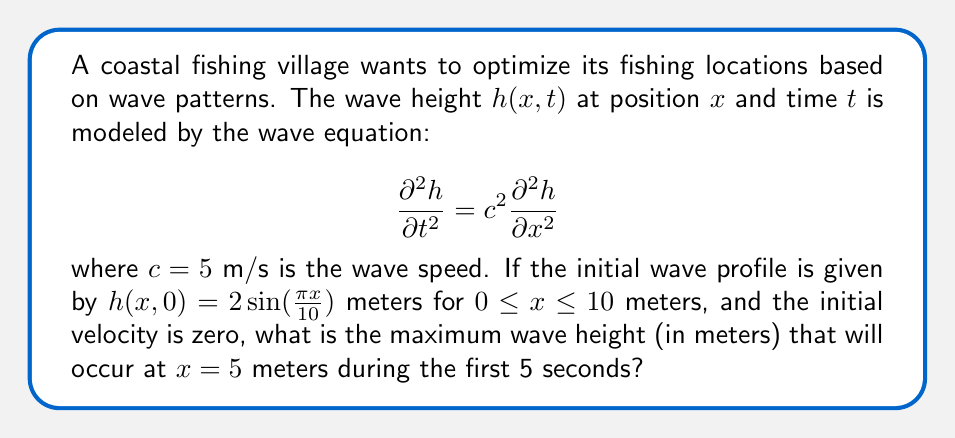Provide a solution to this math problem. To solve this problem, we'll use the general solution for the wave equation with given initial conditions:

1) The general solution for the wave equation is:
   $$h(x,t) = f(x-ct) + g(x+ct)$$

2) Given the initial conditions:
   $h(x,0) = 2\sin(\frac{\pi x}{10})$ and $\frac{\partial h}{\partial t}(x,0) = 0$

3) We can deduce that:
   $$f(x) + g(x) = 2\sin(\frac{\pi x}{10})$$
   $$-cf'(x) + cg'(x) = 0$$

4) Solving these equations leads to:
   $$f(x) = g(x) = \sin(\frac{\pi x}{10})$$

5) Therefore, the solution is:
   $$h(x,t) = \sin(\frac{\pi(x-ct)}{10}) + \sin(\frac{\pi(x+ct)}{10})$$

6) Using trigonometric identities, this can be simplified to:
   $$h(x,t) = 2\sin(\frac{\pi x}{10})\cos(\frac{\pi ct}{10})$$

7) At $x = 5$ meters:
   $$h(5,t) = 2\sin(\frac{\pi 5}{10})\cos(\frac{\pi ct}{10}) = 2\cos(\frac{\pi ct}{10})$$

8) The maximum value of cosine is 1, so the maximum wave height at $x = 5$ meters is 2 meters.

9) This maximum occurs when $\frac{\pi ct}{10} = 0, \pi, 2\pi, ...$
   The first maximum within 5 seconds occurs at $t = 0$ seconds.
Answer: 2 meters 